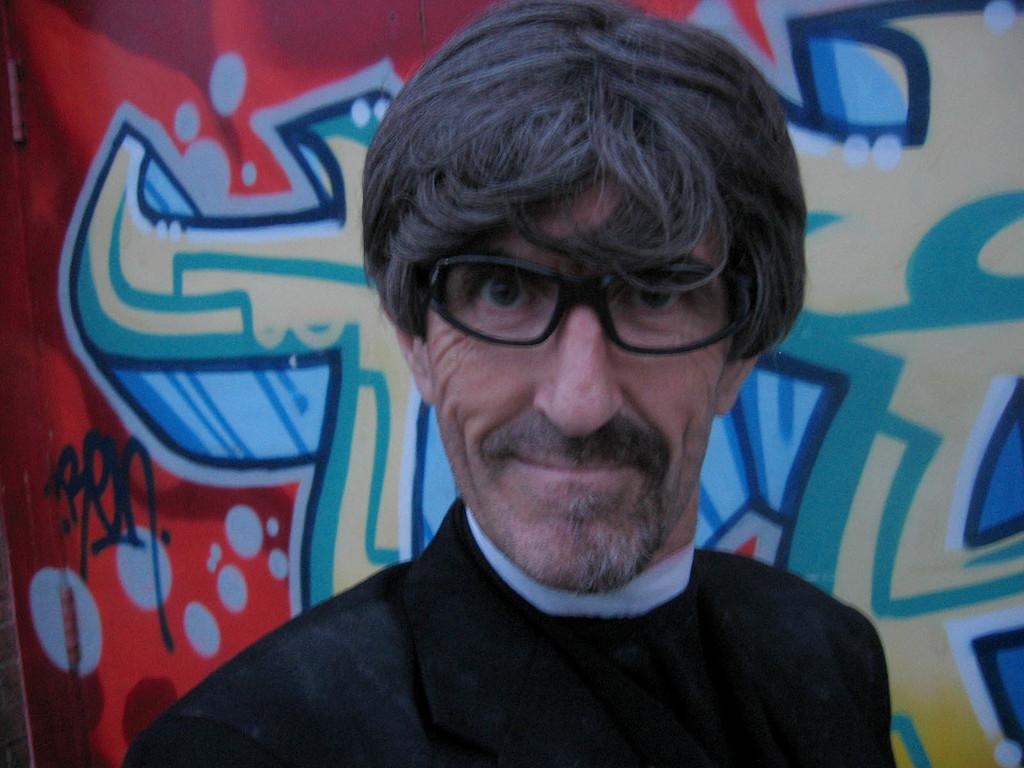Who is present in the image? There is a person in the image. What is the person wearing? The person is wearing a black suit. What can be seen behind the person? There is a wall in the image. What is on the wall? The wall has a painting on it. What type of stone is the person holding in the image? There is no stone present in the image; the person is wearing a black suit and standing in front of a wall with a painting. 